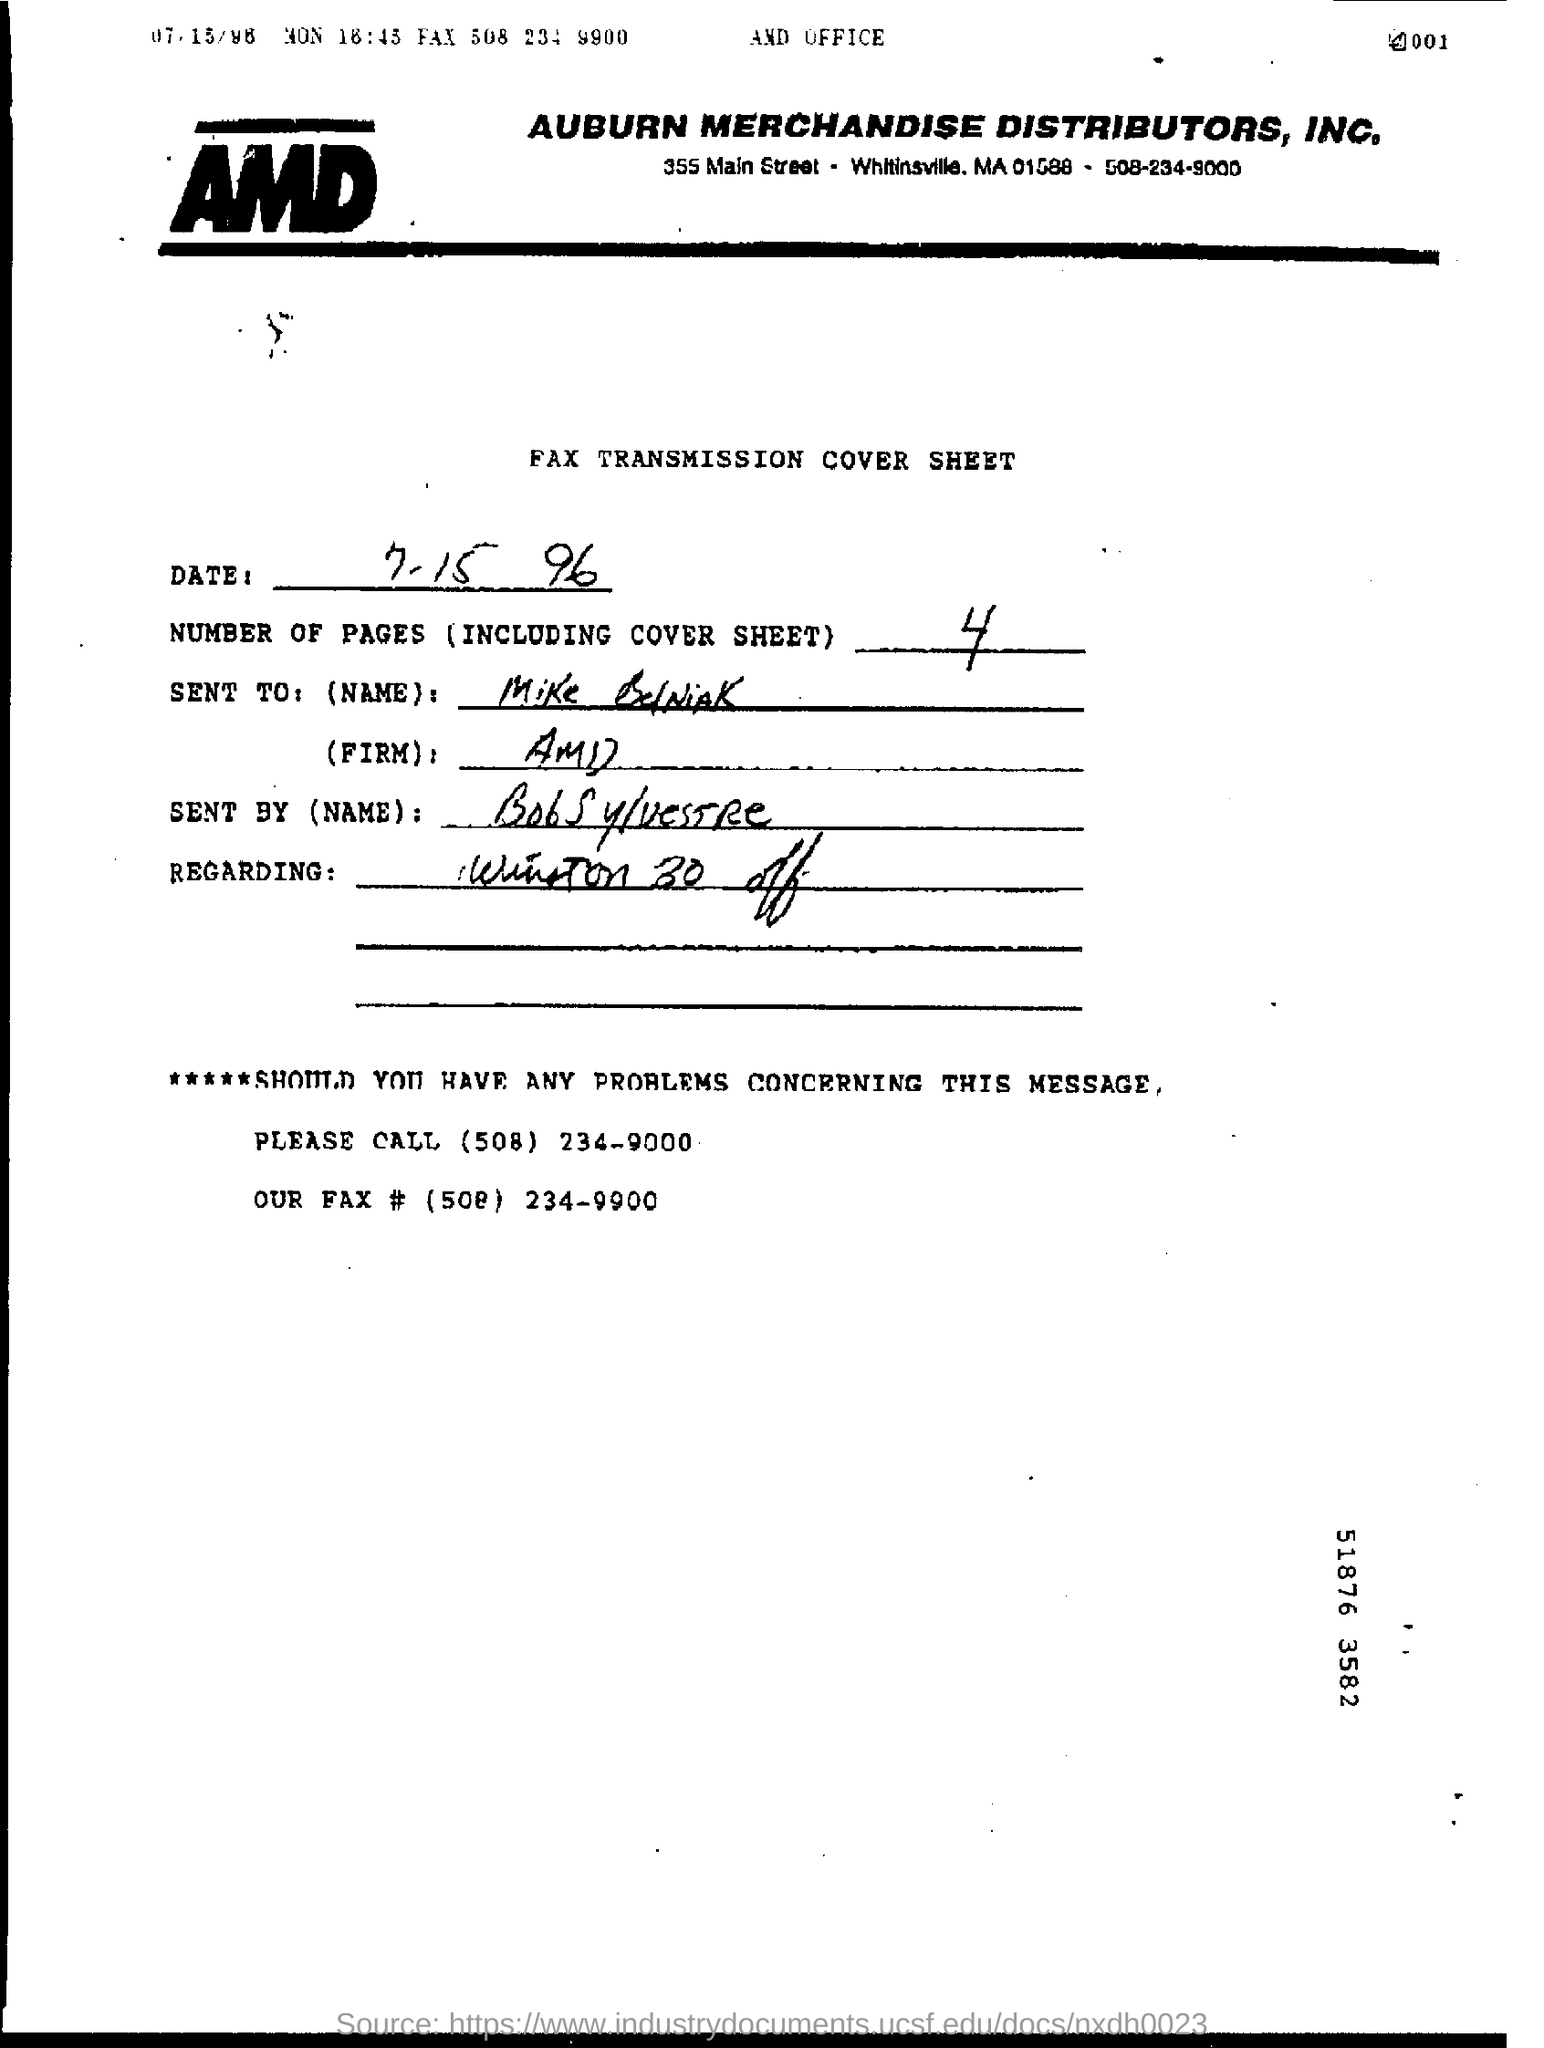Outline some significant characteristics in this image. If you encounter any difficulties, please call the number (508) 234-9000. Auburn Merchandise Distributors, Inc. is the company whose name appears at the top of the page. The fax is addressed to Mike BelNiAK. The date of the fax transmission cover sheet is July 15, 1996. There are 4 pages including the cover sheet in total. 